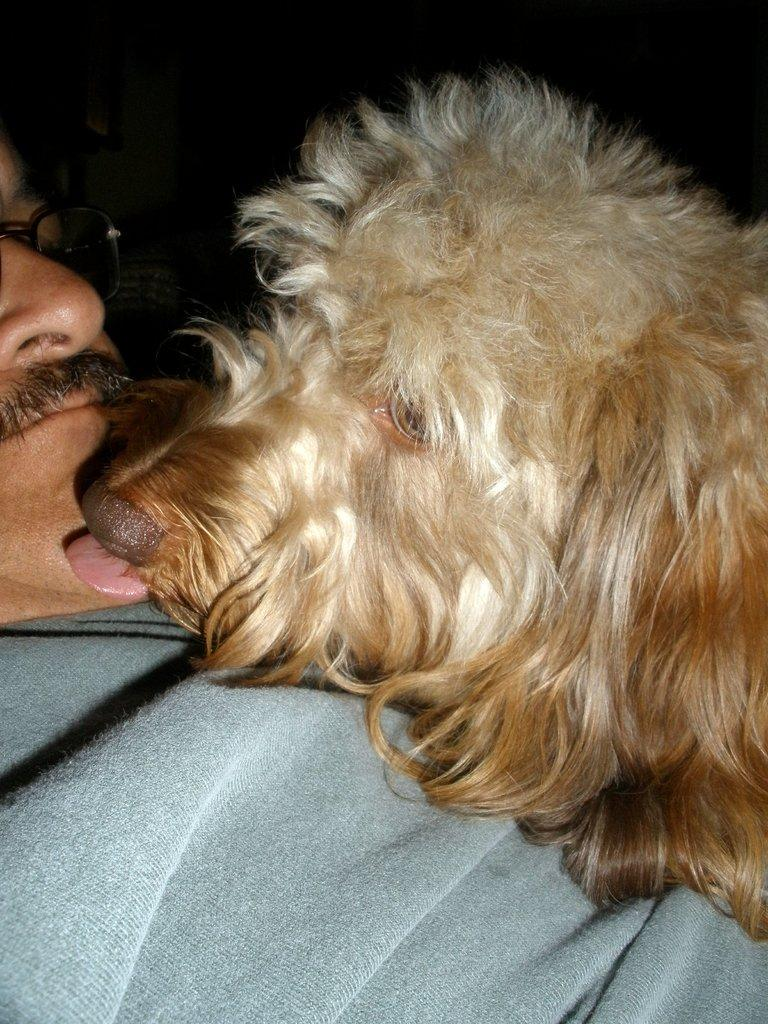What type of animal is in the image? There is a dog in the image. What is the dog doing in the image? The dog is licking a man. What position is the man in the image? The man is lying down. What can be seen on the man's face in the image? The man has spectacles and a mustache. What type of fireman is present in the image? There is no fireman present in the image; it features a dog licking a man. How does the man rub the dog's fur in the image? The image does not show the man rubbing the dog's fur; it shows the dog licking the man. 